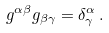Convert formula to latex. <formula><loc_0><loc_0><loc_500><loc_500>g ^ { \alpha \beta } g _ { \beta \gamma } = \delta _ { \gamma } ^ { \alpha } \, .</formula> 